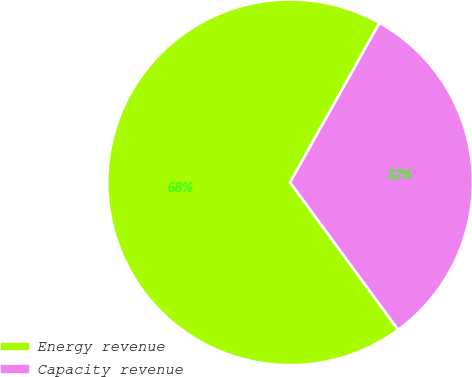Convert chart. <chart><loc_0><loc_0><loc_500><loc_500><pie_chart><fcel>Energy revenue<fcel>Capacity revenue<nl><fcel>68.2%<fcel>31.8%<nl></chart> 